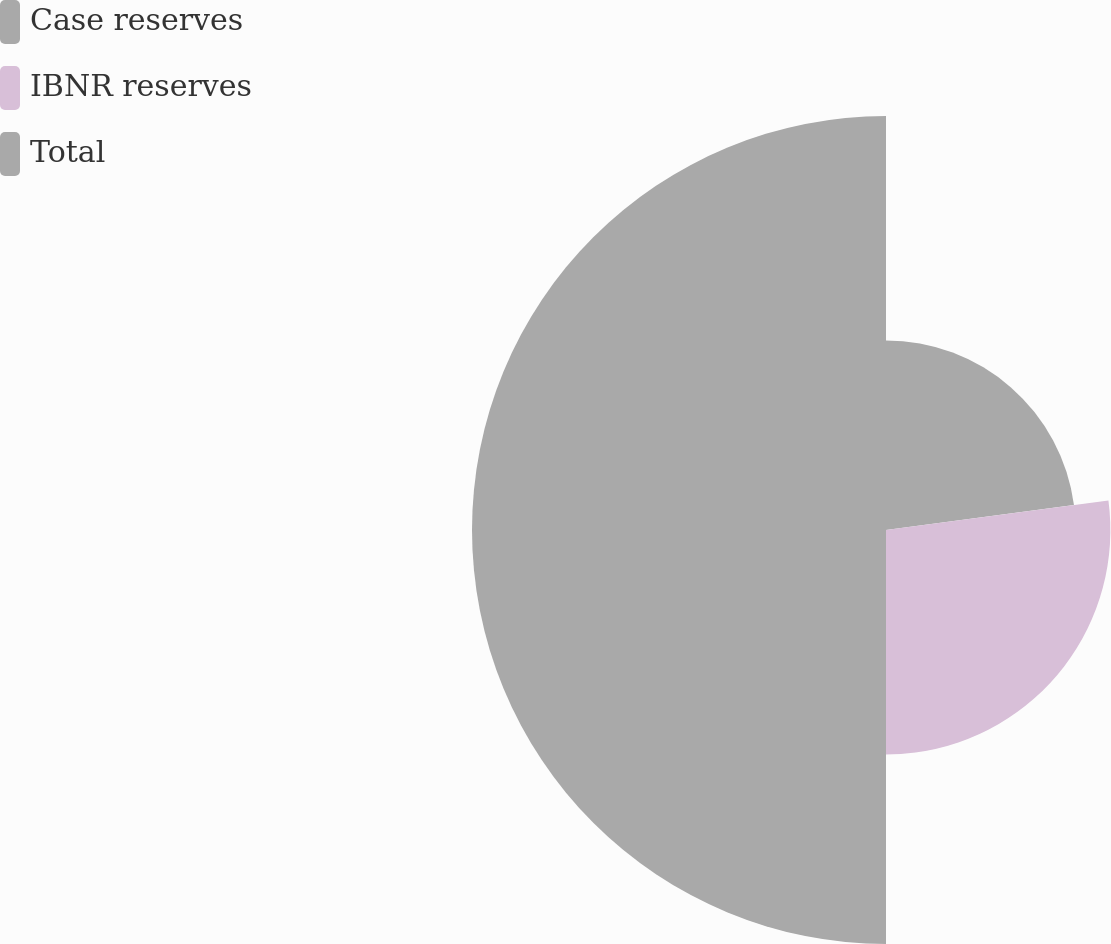Convert chart to OTSL. <chart><loc_0><loc_0><loc_500><loc_500><pie_chart><fcel>Case reserves<fcel>IBNR reserves<fcel>Total<nl><fcel>22.9%<fcel>27.1%<fcel>50.0%<nl></chart> 